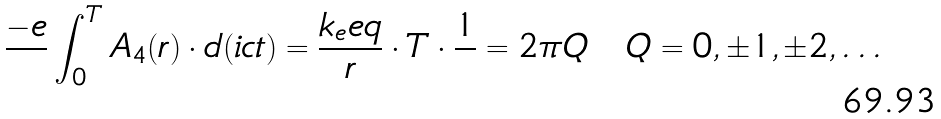Convert formula to latex. <formula><loc_0><loc_0><loc_500><loc_500>\frac { - e } { } \int _ { 0 } ^ { T } A _ { 4 } ( r ) \cdot d ( i c t ) = \frac { k _ { e } e q } { r } \cdot T \cdot \frac { 1 } { } = 2 \pi Q \quad Q = 0 , \pm 1 , \pm 2 , \dots</formula> 